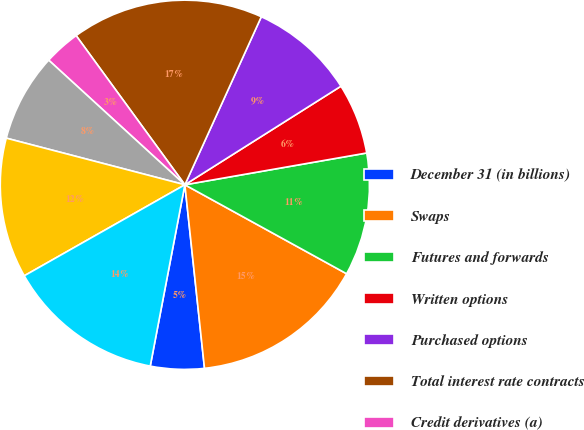<chart> <loc_0><loc_0><loc_500><loc_500><pie_chart><fcel>December 31 (in billions)<fcel>Swaps<fcel>Futures and forwards<fcel>Written options<fcel>Purchased options<fcel>Total interest rate contracts<fcel>Credit derivatives (a)<fcel>Cross-currency swaps<fcel>Spot futures and forwards<fcel>Total foreign exchange<nl><fcel>4.7%<fcel>15.3%<fcel>10.76%<fcel>6.21%<fcel>9.24%<fcel>16.82%<fcel>3.18%<fcel>7.73%<fcel>12.27%<fcel>13.79%<nl></chart> 